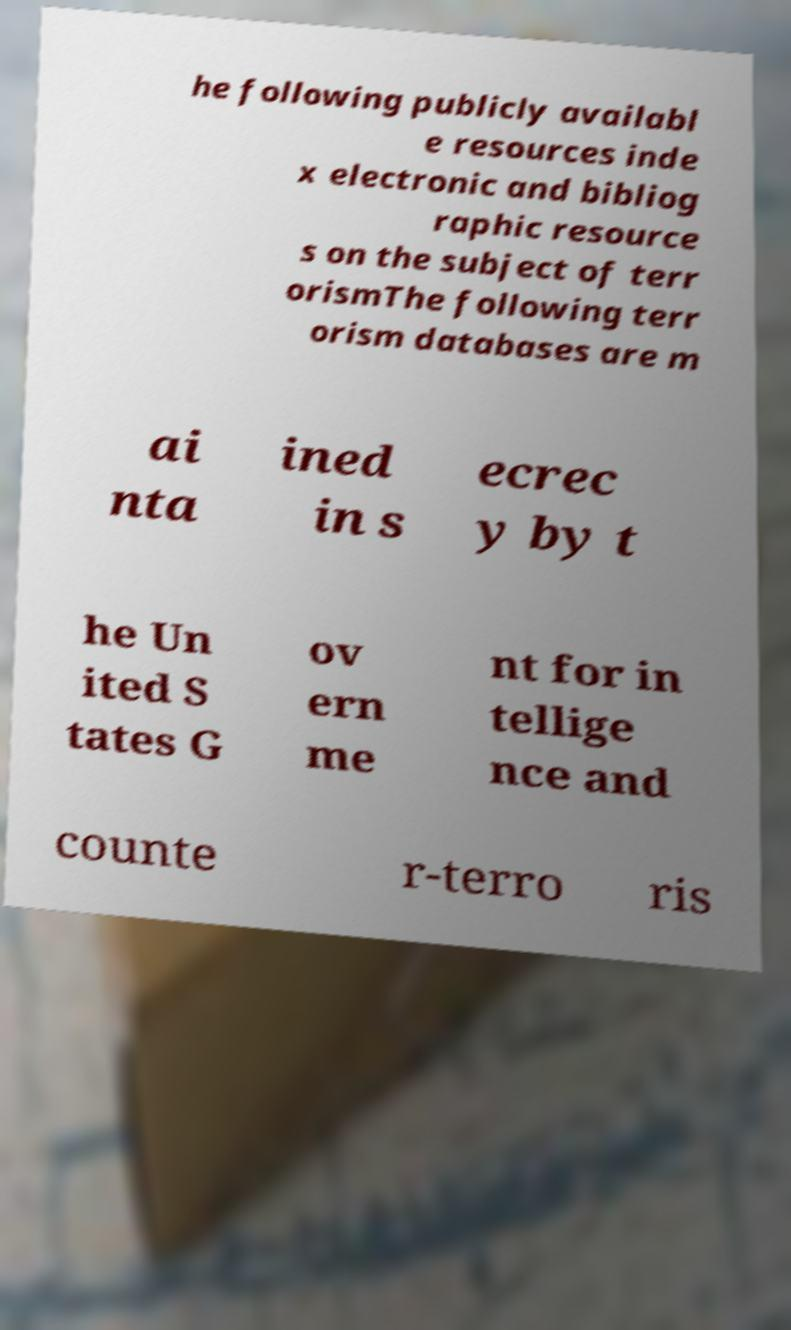Can you accurately transcribe the text from the provided image for me? he following publicly availabl e resources inde x electronic and bibliog raphic resource s on the subject of terr orismThe following terr orism databases are m ai nta ined in s ecrec y by t he Un ited S tates G ov ern me nt for in tellige nce and counte r-terro ris 